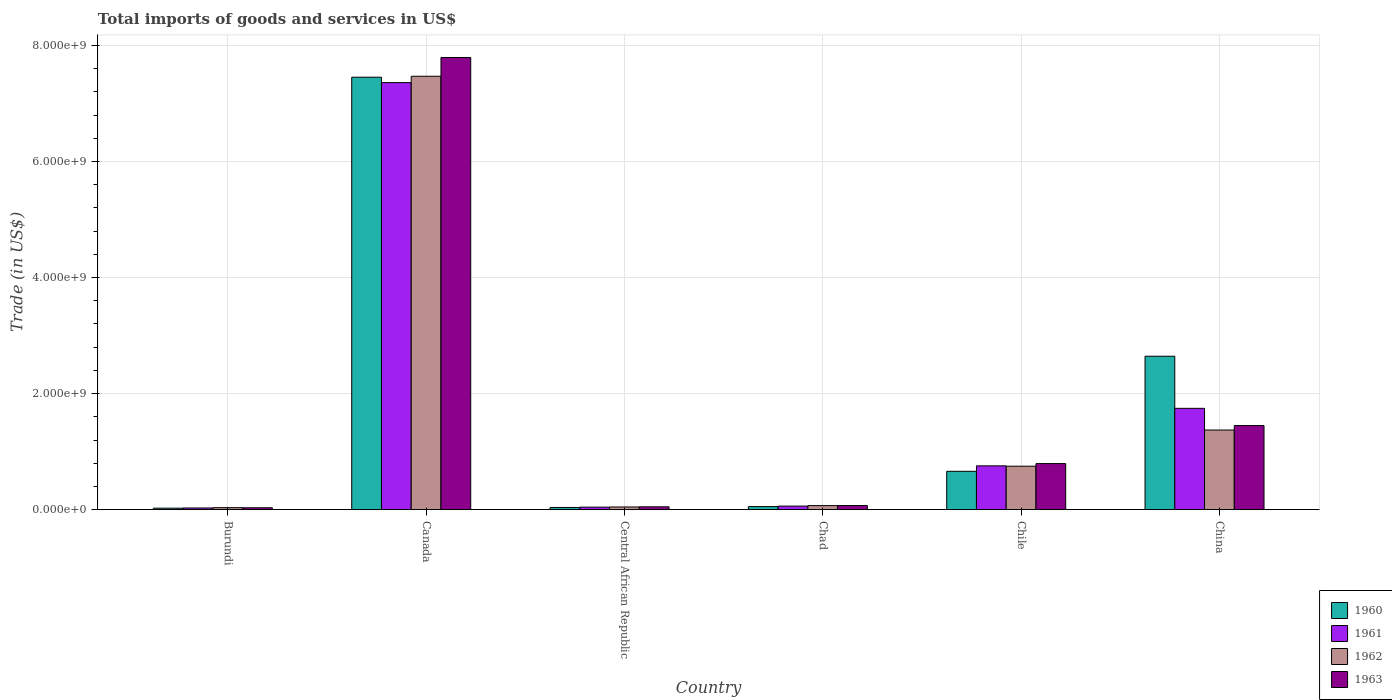How many different coloured bars are there?
Your response must be concise. 4. Are the number of bars on each tick of the X-axis equal?
Keep it short and to the point. Yes. How many bars are there on the 4th tick from the left?
Provide a short and direct response. 4. What is the label of the 1st group of bars from the left?
Provide a succinct answer. Burundi. What is the total imports of goods and services in 1961 in China?
Provide a short and direct response. 1.75e+09. Across all countries, what is the maximum total imports of goods and services in 1962?
Offer a very short reply. 7.47e+09. Across all countries, what is the minimum total imports of goods and services in 1960?
Offer a very short reply. 2.62e+07. In which country was the total imports of goods and services in 1963 minimum?
Offer a terse response. Burundi. What is the total total imports of goods and services in 1961 in the graph?
Provide a succinct answer. 1.00e+1. What is the difference between the total imports of goods and services in 1962 in Central African Republic and that in China?
Offer a very short reply. -1.33e+09. What is the difference between the total imports of goods and services in 1960 in Burundi and the total imports of goods and services in 1961 in Central African Republic?
Ensure brevity in your answer.  -1.78e+07. What is the average total imports of goods and services in 1960 per country?
Ensure brevity in your answer.  1.81e+09. What is the difference between the total imports of goods and services of/in 1963 and total imports of goods and services of/in 1961 in Central African Republic?
Give a very brief answer. 5.76e+06. What is the ratio of the total imports of goods and services in 1963 in Burundi to that in Chad?
Ensure brevity in your answer.  0.47. Is the total imports of goods and services in 1963 in Canada less than that in Chile?
Your answer should be very brief. No. Is the difference between the total imports of goods and services in 1963 in Burundi and Canada greater than the difference between the total imports of goods and services in 1961 in Burundi and Canada?
Your answer should be very brief. No. What is the difference between the highest and the second highest total imports of goods and services in 1960?
Your answer should be very brief. -1.98e+09. What is the difference between the highest and the lowest total imports of goods and services in 1961?
Your response must be concise. 7.33e+09. In how many countries, is the total imports of goods and services in 1963 greater than the average total imports of goods and services in 1963 taken over all countries?
Provide a short and direct response. 1. Is the sum of the total imports of goods and services in 1963 in Central African Republic and China greater than the maximum total imports of goods and services in 1960 across all countries?
Provide a succinct answer. No. What does the 3rd bar from the left in Burundi represents?
Keep it short and to the point. 1962. What does the 2nd bar from the right in Canada represents?
Give a very brief answer. 1962. Is it the case that in every country, the sum of the total imports of goods and services in 1962 and total imports of goods and services in 1960 is greater than the total imports of goods and services in 1963?
Ensure brevity in your answer.  Yes. How many countries are there in the graph?
Your answer should be very brief. 6. Does the graph contain any zero values?
Keep it short and to the point. No. Does the graph contain grids?
Offer a terse response. Yes. What is the title of the graph?
Your answer should be compact. Total imports of goods and services in US$. What is the label or title of the X-axis?
Provide a succinct answer. Country. What is the label or title of the Y-axis?
Your answer should be compact. Trade (in US$). What is the Trade (in US$) in 1960 in Burundi?
Keep it short and to the point. 2.62e+07. What is the Trade (in US$) in 1961 in Burundi?
Provide a succinct answer. 2.98e+07. What is the Trade (in US$) in 1962 in Burundi?
Make the answer very short. 3.50e+07. What is the Trade (in US$) of 1963 in Burundi?
Your answer should be very brief. 3.32e+07. What is the Trade (in US$) of 1960 in Canada?
Give a very brief answer. 7.45e+09. What is the Trade (in US$) in 1961 in Canada?
Make the answer very short. 7.36e+09. What is the Trade (in US$) in 1962 in Canada?
Offer a terse response. 7.47e+09. What is the Trade (in US$) of 1963 in Canada?
Offer a very short reply. 7.79e+09. What is the Trade (in US$) of 1960 in Central African Republic?
Make the answer very short. 3.83e+07. What is the Trade (in US$) in 1961 in Central African Republic?
Give a very brief answer. 4.40e+07. What is the Trade (in US$) of 1962 in Central African Republic?
Your answer should be compact. 4.69e+07. What is the Trade (in US$) in 1963 in Central African Republic?
Your answer should be compact. 4.98e+07. What is the Trade (in US$) of 1960 in Chad?
Give a very brief answer. 5.34e+07. What is the Trade (in US$) in 1961 in Chad?
Ensure brevity in your answer.  6.20e+07. What is the Trade (in US$) of 1962 in Chad?
Offer a very short reply. 7.02e+07. What is the Trade (in US$) in 1963 in Chad?
Offer a very short reply. 7.14e+07. What is the Trade (in US$) in 1960 in Chile?
Offer a very short reply. 6.62e+08. What is the Trade (in US$) of 1961 in Chile?
Provide a succinct answer. 7.55e+08. What is the Trade (in US$) of 1962 in Chile?
Your response must be concise. 7.50e+08. What is the Trade (in US$) of 1963 in Chile?
Offer a terse response. 7.95e+08. What is the Trade (in US$) of 1960 in China?
Ensure brevity in your answer.  2.64e+09. What is the Trade (in US$) in 1961 in China?
Ensure brevity in your answer.  1.75e+09. What is the Trade (in US$) of 1962 in China?
Make the answer very short. 1.37e+09. What is the Trade (in US$) of 1963 in China?
Ensure brevity in your answer.  1.45e+09. Across all countries, what is the maximum Trade (in US$) in 1960?
Make the answer very short. 7.45e+09. Across all countries, what is the maximum Trade (in US$) in 1961?
Keep it short and to the point. 7.36e+09. Across all countries, what is the maximum Trade (in US$) in 1962?
Ensure brevity in your answer.  7.47e+09. Across all countries, what is the maximum Trade (in US$) of 1963?
Offer a terse response. 7.79e+09. Across all countries, what is the minimum Trade (in US$) of 1960?
Make the answer very short. 2.62e+07. Across all countries, what is the minimum Trade (in US$) of 1961?
Give a very brief answer. 2.98e+07. Across all countries, what is the minimum Trade (in US$) in 1962?
Keep it short and to the point. 3.50e+07. Across all countries, what is the minimum Trade (in US$) in 1963?
Provide a short and direct response. 3.32e+07. What is the total Trade (in US$) of 1960 in the graph?
Provide a short and direct response. 1.09e+1. What is the total Trade (in US$) in 1961 in the graph?
Your answer should be compact. 1.00e+1. What is the total Trade (in US$) of 1962 in the graph?
Your answer should be compact. 9.74e+09. What is the total Trade (in US$) in 1963 in the graph?
Offer a very short reply. 1.02e+1. What is the difference between the Trade (in US$) of 1960 in Burundi and that in Canada?
Offer a terse response. -7.43e+09. What is the difference between the Trade (in US$) of 1961 in Burundi and that in Canada?
Offer a terse response. -7.33e+09. What is the difference between the Trade (in US$) of 1962 in Burundi and that in Canada?
Provide a short and direct response. -7.43e+09. What is the difference between the Trade (in US$) in 1963 in Burundi and that in Canada?
Ensure brevity in your answer.  -7.76e+09. What is the difference between the Trade (in US$) of 1960 in Burundi and that in Central African Republic?
Provide a succinct answer. -1.21e+07. What is the difference between the Trade (in US$) in 1961 in Burundi and that in Central African Republic?
Offer a terse response. -1.43e+07. What is the difference between the Trade (in US$) in 1962 in Burundi and that in Central African Republic?
Provide a succinct answer. -1.19e+07. What is the difference between the Trade (in US$) in 1963 in Burundi and that in Central African Republic?
Offer a terse response. -1.65e+07. What is the difference between the Trade (in US$) of 1960 in Burundi and that in Chad?
Your answer should be very brief. -2.72e+07. What is the difference between the Trade (in US$) of 1961 in Burundi and that in Chad?
Ensure brevity in your answer.  -3.22e+07. What is the difference between the Trade (in US$) in 1962 in Burundi and that in Chad?
Your answer should be very brief. -3.52e+07. What is the difference between the Trade (in US$) of 1963 in Burundi and that in Chad?
Offer a terse response. -3.82e+07. What is the difference between the Trade (in US$) in 1960 in Burundi and that in Chile?
Provide a succinct answer. -6.35e+08. What is the difference between the Trade (in US$) of 1961 in Burundi and that in Chile?
Make the answer very short. -7.26e+08. What is the difference between the Trade (in US$) of 1962 in Burundi and that in Chile?
Your answer should be compact. -7.15e+08. What is the difference between the Trade (in US$) in 1963 in Burundi and that in Chile?
Keep it short and to the point. -7.61e+08. What is the difference between the Trade (in US$) in 1960 in Burundi and that in China?
Your answer should be compact. -2.62e+09. What is the difference between the Trade (in US$) in 1961 in Burundi and that in China?
Give a very brief answer. -1.72e+09. What is the difference between the Trade (in US$) of 1962 in Burundi and that in China?
Offer a terse response. -1.34e+09. What is the difference between the Trade (in US$) in 1963 in Burundi and that in China?
Your answer should be very brief. -1.42e+09. What is the difference between the Trade (in US$) in 1960 in Canada and that in Central African Republic?
Provide a succinct answer. 7.41e+09. What is the difference between the Trade (in US$) in 1961 in Canada and that in Central African Republic?
Your answer should be very brief. 7.32e+09. What is the difference between the Trade (in US$) of 1962 in Canada and that in Central African Republic?
Ensure brevity in your answer.  7.42e+09. What is the difference between the Trade (in US$) of 1963 in Canada and that in Central African Republic?
Provide a short and direct response. 7.74e+09. What is the difference between the Trade (in US$) in 1960 in Canada and that in Chad?
Give a very brief answer. 7.40e+09. What is the difference between the Trade (in US$) of 1961 in Canada and that in Chad?
Ensure brevity in your answer.  7.30e+09. What is the difference between the Trade (in US$) in 1962 in Canada and that in Chad?
Your response must be concise. 7.40e+09. What is the difference between the Trade (in US$) in 1963 in Canada and that in Chad?
Give a very brief answer. 7.72e+09. What is the difference between the Trade (in US$) of 1960 in Canada and that in Chile?
Offer a very short reply. 6.79e+09. What is the difference between the Trade (in US$) of 1961 in Canada and that in Chile?
Offer a very short reply. 6.60e+09. What is the difference between the Trade (in US$) in 1962 in Canada and that in Chile?
Ensure brevity in your answer.  6.72e+09. What is the difference between the Trade (in US$) in 1963 in Canada and that in Chile?
Give a very brief answer. 7.00e+09. What is the difference between the Trade (in US$) in 1960 in Canada and that in China?
Ensure brevity in your answer.  4.81e+09. What is the difference between the Trade (in US$) of 1961 in Canada and that in China?
Provide a succinct answer. 5.61e+09. What is the difference between the Trade (in US$) in 1962 in Canada and that in China?
Your response must be concise. 6.10e+09. What is the difference between the Trade (in US$) of 1963 in Canada and that in China?
Your answer should be very brief. 6.34e+09. What is the difference between the Trade (in US$) in 1960 in Central African Republic and that in Chad?
Provide a short and direct response. -1.51e+07. What is the difference between the Trade (in US$) in 1961 in Central African Republic and that in Chad?
Your response must be concise. -1.79e+07. What is the difference between the Trade (in US$) in 1962 in Central African Republic and that in Chad?
Offer a terse response. -2.33e+07. What is the difference between the Trade (in US$) in 1963 in Central African Republic and that in Chad?
Offer a very short reply. -2.16e+07. What is the difference between the Trade (in US$) in 1960 in Central African Republic and that in Chile?
Make the answer very short. -6.23e+08. What is the difference between the Trade (in US$) in 1961 in Central African Republic and that in Chile?
Your answer should be very brief. -7.11e+08. What is the difference between the Trade (in US$) of 1962 in Central African Republic and that in Chile?
Your answer should be very brief. -7.03e+08. What is the difference between the Trade (in US$) in 1963 in Central African Republic and that in Chile?
Make the answer very short. -7.45e+08. What is the difference between the Trade (in US$) of 1960 in Central African Republic and that in China?
Provide a succinct answer. -2.61e+09. What is the difference between the Trade (in US$) of 1961 in Central African Republic and that in China?
Provide a short and direct response. -1.70e+09. What is the difference between the Trade (in US$) of 1962 in Central African Republic and that in China?
Keep it short and to the point. -1.33e+09. What is the difference between the Trade (in US$) in 1963 in Central African Republic and that in China?
Your answer should be compact. -1.40e+09. What is the difference between the Trade (in US$) in 1960 in Chad and that in Chile?
Your answer should be compact. -6.08e+08. What is the difference between the Trade (in US$) in 1961 in Chad and that in Chile?
Provide a succinct answer. -6.93e+08. What is the difference between the Trade (in US$) of 1962 in Chad and that in Chile?
Provide a short and direct response. -6.80e+08. What is the difference between the Trade (in US$) of 1963 in Chad and that in Chile?
Give a very brief answer. -7.23e+08. What is the difference between the Trade (in US$) of 1960 in Chad and that in China?
Your answer should be compact. -2.59e+09. What is the difference between the Trade (in US$) in 1961 in Chad and that in China?
Make the answer very short. -1.68e+09. What is the difference between the Trade (in US$) of 1962 in Chad and that in China?
Your answer should be compact. -1.30e+09. What is the difference between the Trade (in US$) in 1963 in Chad and that in China?
Offer a very short reply. -1.38e+09. What is the difference between the Trade (in US$) in 1960 in Chile and that in China?
Your answer should be compact. -1.98e+09. What is the difference between the Trade (in US$) in 1961 in Chile and that in China?
Your answer should be compact. -9.91e+08. What is the difference between the Trade (in US$) of 1962 in Chile and that in China?
Keep it short and to the point. -6.23e+08. What is the difference between the Trade (in US$) in 1963 in Chile and that in China?
Offer a terse response. -6.55e+08. What is the difference between the Trade (in US$) in 1960 in Burundi and the Trade (in US$) in 1961 in Canada?
Make the answer very short. -7.33e+09. What is the difference between the Trade (in US$) of 1960 in Burundi and the Trade (in US$) of 1962 in Canada?
Your answer should be compact. -7.44e+09. What is the difference between the Trade (in US$) in 1960 in Burundi and the Trade (in US$) in 1963 in Canada?
Keep it short and to the point. -7.77e+09. What is the difference between the Trade (in US$) of 1961 in Burundi and the Trade (in US$) of 1962 in Canada?
Your answer should be very brief. -7.44e+09. What is the difference between the Trade (in US$) of 1961 in Burundi and the Trade (in US$) of 1963 in Canada?
Make the answer very short. -7.76e+09. What is the difference between the Trade (in US$) of 1962 in Burundi and the Trade (in US$) of 1963 in Canada?
Provide a succinct answer. -7.76e+09. What is the difference between the Trade (in US$) in 1960 in Burundi and the Trade (in US$) in 1961 in Central African Republic?
Your answer should be compact. -1.78e+07. What is the difference between the Trade (in US$) in 1960 in Burundi and the Trade (in US$) in 1962 in Central African Republic?
Offer a very short reply. -2.07e+07. What is the difference between the Trade (in US$) in 1960 in Burundi and the Trade (in US$) in 1963 in Central African Republic?
Give a very brief answer. -2.35e+07. What is the difference between the Trade (in US$) of 1961 in Burundi and the Trade (in US$) of 1962 in Central African Republic?
Your answer should be compact. -1.72e+07. What is the difference between the Trade (in US$) in 1961 in Burundi and the Trade (in US$) in 1963 in Central African Republic?
Your answer should be very brief. -2.00e+07. What is the difference between the Trade (in US$) in 1962 in Burundi and the Trade (in US$) in 1963 in Central African Republic?
Make the answer very short. -1.48e+07. What is the difference between the Trade (in US$) in 1960 in Burundi and the Trade (in US$) in 1961 in Chad?
Your answer should be very brief. -3.57e+07. What is the difference between the Trade (in US$) of 1960 in Burundi and the Trade (in US$) of 1962 in Chad?
Offer a terse response. -4.40e+07. What is the difference between the Trade (in US$) of 1960 in Burundi and the Trade (in US$) of 1963 in Chad?
Your answer should be compact. -4.52e+07. What is the difference between the Trade (in US$) in 1961 in Burundi and the Trade (in US$) in 1962 in Chad?
Offer a terse response. -4.05e+07. What is the difference between the Trade (in US$) in 1961 in Burundi and the Trade (in US$) in 1963 in Chad?
Keep it short and to the point. -4.17e+07. What is the difference between the Trade (in US$) of 1962 in Burundi and the Trade (in US$) of 1963 in Chad?
Provide a short and direct response. -3.64e+07. What is the difference between the Trade (in US$) in 1960 in Burundi and the Trade (in US$) in 1961 in Chile?
Make the answer very short. -7.29e+08. What is the difference between the Trade (in US$) in 1960 in Burundi and the Trade (in US$) in 1962 in Chile?
Your response must be concise. -7.23e+08. What is the difference between the Trade (in US$) in 1960 in Burundi and the Trade (in US$) in 1963 in Chile?
Keep it short and to the point. -7.68e+08. What is the difference between the Trade (in US$) of 1961 in Burundi and the Trade (in US$) of 1962 in Chile?
Your answer should be compact. -7.20e+08. What is the difference between the Trade (in US$) in 1961 in Burundi and the Trade (in US$) in 1963 in Chile?
Offer a terse response. -7.65e+08. What is the difference between the Trade (in US$) in 1962 in Burundi and the Trade (in US$) in 1963 in Chile?
Offer a terse response. -7.60e+08. What is the difference between the Trade (in US$) in 1960 in Burundi and the Trade (in US$) in 1961 in China?
Keep it short and to the point. -1.72e+09. What is the difference between the Trade (in US$) in 1960 in Burundi and the Trade (in US$) in 1962 in China?
Offer a very short reply. -1.35e+09. What is the difference between the Trade (in US$) in 1960 in Burundi and the Trade (in US$) in 1963 in China?
Keep it short and to the point. -1.42e+09. What is the difference between the Trade (in US$) of 1961 in Burundi and the Trade (in US$) of 1962 in China?
Keep it short and to the point. -1.34e+09. What is the difference between the Trade (in US$) of 1961 in Burundi and the Trade (in US$) of 1963 in China?
Provide a short and direct response. -1.42e+09. What is the difference between the Trade (in US$) of 1962 in Burundi and the Trade (in US$) of 1963 in China?
Your answer should be very brief. -1.42e+09. What is the difference between the Trade (in US$) in 1960 in Canada and the Trade (in US$) in 1961 in Central African Republic?
Ensure brevity in your answer.  7.41e+09. What is the difference between the Trade (in US$) of 1960 in Canada and the Trade (in US$) of 1962 in Central African Republic?
Provide a succinct answer. 7.41e+09. What is the difference between the Trade (in US$) of 1960 in Canada and the Trade (in US$) of 1963 in Central African Republic?
Your response must be concise. 7.40e+09. What is the difference between the Trade (in US$) in 1961 in Canada and the Trade (in US$) in 1962 in Central African Republic?
Your answer should be compact. 7.31e+09. What is the difference between the Trade (in US$) in 1961 in Canada and the Trade (in US$) in 1963 in Central African Republic?
Keep it short and to the point. 7.31e+09. What is the difference between the Trade (in US$) of 1962 in Canada and the Trade (in US$) of 1963 in Central African Republic?
Ensure brevity in your answer.  7.42e+09. What is the difference between the Trade (in US$) of 1960 in Canada and the Trade (in US$) of 1961 in Chad?
Your response must be concise. 7.39e+09. What is the difference between the Trade (in US$) in 1960 in Canada and the Trade (in US$) in 1962 in Chad?
Your answer should be very brief. 7.38e+09. What is the difference between the Trade (in US$) in 1960 in Canada and the Trade (in US$) in 1963 in Chad?
Offer a terse response. 7.38e+09. What is the difference between the Trade (in US$) of 1961 in Canada and the Trade (in US$) of 1962 in Chad?
Your answer should be compact. 7.29e+09. What is the difference between the Trade (in US$) in 1961 in Canada and the Trade (in US$) in 1963 in Chad?
Your response must be concise. 7.29e+09. What is the difference between the Trade (in US$) of 1962 in Canada and the Trade (in US$) of 1963 in Chad?
Give a very brief answer. 7.40e+09. What is the difference between the Trade (in US$) in 1960 in Canada and the Trade (in US$) in 1961 in Chile?
Provide a succinct answer. 6.70e+09. What is the difference between the Trade (in US$) of 1960 in Canada and the Trade (in US$) of 1962 in Chile?
Your answer should be very brief. 6.70e+09. What is the difference between the Trade (in US$) in 1960 in Canada and the Trade (in US$) in 1963 in Chile?
Ensure brevity in your answer.  6.66e+09. What is the difference between the Trade (in US$) in 1961 in Canada and the Trade (in US$) in 1962 in Chile?
Make the answer very short. 6.61e+09. What is the difference between the Trade (in US$) in 1961 in Canada and the Trade (in US$) in 1963 in Chile?
Give a very brief answer. 6.56e+09. What is the difference between the Trade (in US$) of 1962 in Canada and the Trade (in US$) of 1963 in Chile?
Provide a succinct answer. 6.67e+09. What is the difference between the Trade (in US$) of 1960 in Canada and the Trade (in US$) of 1961 in China?
Offer a terse response. 5.71e+09. What is the difference between the Trade (in US$) of 1960 in Canada and the Trade (in US$) of 1962 in China?
Offer a very short reply. 6.08e+09. What is the difference between the Trade (in US$) in 1960 in Canada and the Trade (in US$) in 1963 in China?
Offer a terse response. 6.00e+09. What is the difference between the Trade (in US$) in 1961 in Canada and the Trade (in US$) in 1962 in China?
Offer a terse response. 5.99e+09. What is the difference between the Trade (in US$) in 1961 in Canada and the Trade (in US$) in 1963 in China?
Your answer should be compact. 5.91e+09. What is the difference between the Trade (in US$) in 1962 in Canada and the Trade (in US$) in 1963 in China?
Your response must be concise. 6.02e+09. What is the difference between the Trade (in US$) of 1960 in Central African Republic and the Trade (in US$) of 1961 in Chad?
Provide a short and direct response. -2.36e+07. What is the difference between the Trade (in US$) in 1960 in Central African Republic and the Trade (in US$) in 1962 in Chad?
Provide a succinct answer. -3.19e+07. What is the difference between the Trade (in US$) in 1960 in Central African Republic and the Trade (in US$) in 1963 in Chad?
Make the answer very short. -3.31e+07. What is the difference between the Trade (in US$) in 1961 in Central African Republic and the Trade (in US$) in 1962 in Chad?
Provide a succinct answer. -2.62e+07. What is the difference between the Trade (in US$) in 1961 in Central African Republic and the Trade (in US$) in 1963 in Chad?
Your answer should be very brief. -2.74e+07. What is the difference between the Trade (in US$) in 1962 in Central African Republic and the Trade (in US$) in 1963 in Chad?
Offer a very short reply. -2.45e+07. What is the difference between the Trade (in US$) in 1960 in Central African Republic and the Trade (in US$) in 1961 in Chile?
Offer a terse response. -7.17e+08. What is the difference between the Trade (in US$) of 1960 in Central African Republic and the Trade (in US$) of 1962 in Chile?
Your answer should be very brief. -7.11e+08. What is the difference between the Trade (in US$) of 1960 in Central African Republic and the Trade (in US$) of 1963 in Chile?
Offer a terse response. -7.56e+08. What is the difference between the Trade (in US$) in 1961 in Central African Republic and the Trade (in US$) in 1962 in Chile?
Provide a succinct answer. -7.06e+08. What is the difference between the Trade (in US$) in 1961 in Central African Republic and the Trade (in US$) in 1963 in Chile?
Provide a succinct answer. -7.51e+08. What is the difference between the Trade (in US$) of 1962 in Central African Republic and the Trade (in US$) of 1963 in Chile?
Provide a short and direct response. -7.48e+08. What is the difference between the Trade (in US$) in 1960 in Central African Republic and the Trade (in US$) in 1961 in China?
Ensure brevity in your answer.  -1.71e+09. What is the difference between the Trade (in US$) of 1960 in Central African Republic and the Trade (in US$) of 1962 in China?
Provide a succinct answer. -1.33e+09. What is the difference between the Trade (in US$) in 1960 in Central African Republic and the Trade (in US$) in 1963 in China?
Offer a very short reply. -1.41e+09. What is the difference between the Trade (in US$) in 1961 in Central African Republic and the Trade (in US$) in 1962 in China?
Provide a short and direct response. -1.33e+09. What is the difference between the Trade (in US$) in 1961 in Central African Republic and the Trade (in US$) in 1963 in China?
Your answer should be compact. -1.41e+09. What is the difference between the Trade (in US$) of 1962 in Central African Republic and the Trade (in US$) of 1963 in China?
Offer a terse response. -1.40e+09. What is the difference between the Trade (in US$) of 1960 in Chad and the Trade (in US$) of 1961 in Chile?
Offer a terse response. -7.02e+08. What is the difference between the Trade (in US$) in 1960 in Chad and the Trade (in US$) in 1962 in Chile?
Provide a succinct answer. -6.96e+08. What is the difference between the Trade (in US$) in 1960 in Chad and the Trade (in US$) in 1963 in Chile?
Keep it short and to the point. -7.41e+08. What is the difference between the Trade (in US$) of 1961 in Chad and the Trade (in US$) of 1962 in Chile?
Your answer should be very brief. -6.88e+08. What is the difference between the Trade (in US$) in 1961 in Chad and the Trade (in US$) in 1963 in Chile?
Give a very brief answer. -7.33e+08. What is the difference between the Trade (in US$) in 1962 in Chad and the Trade (in US$) in 1963 in Chile?
Your answer should be compact. -7.25e+08. What is the difference between the Trade (in US$) in 1960 in Chad and the Trade (in US$) in 1961 in China?
Your answer should be compact. -1.69e+09. What is the difference between the Trade (in US$) of 1960 in Chad and the Trade (in US$) of 1962 in China?
Keep it short and to the point. -1.32e+09. What is the difference between the Trade (in US$) of 1960 in Chad and the Trade (in US$) of 1963 in China?
Offer a very short reply. -1.40e+09. What is the difference between the Trade (in US$) of 1961 in Chad and the Trade (in US$) of 1962 in China?
Offer a terse response. -1.31e+09. What is the difference between the Trade (in US$) of 1961 in Chad and the Trade (in US$) of 1963 in China?
Provide a short and direct response. -1.39e+09. What is the difference between the Trade (in US$) in 1962 in Chad and the Trade (in US$) in 1963 in China?
Your response must be concise. -1.38e+09. What is the difference between the Trade (in US$) in 1960 in Chile and the Trade (in US$) in 1961 in China?
Give a very brief answer. -1.09e+09. What is the difference between the Trade (in US$) of 1960 in Chile and the Trade (in US$) of 1962 in China?
Provide a succinct answer. -7.11e+08. What is the difference between the Trade (in US$) in 1960 in Chile and the Trade (in US$) in 1963 in China?
Your response must be concise. -7.88e+08. What is the difference between the Trade (in US$) in 1961 in Chile and the Trade (in US$) in 1962 in China?
Give a very brief answer. -6.18e+08. What is the difference between the Trade (in US$) of 1961 in Chile and the Trade (in US$) of 1963 in China?
Keep it short and to the point. -6.95e+08. What is the difference between the Trade (in US$) of 1962 in Chile and the Trade (in US$) of 1963 in China?
Ensure brevity in your answer.  -7.00e+08. What is the average Trade (in US$) in 1960 per country?
Provide a short and direct response. 1.81e+09. What is the average Trade (in US$) of 1961 per country?
Ensure brevity in your answer.  1.67e+09. What is the average Trade (in US$) in 1962 per country?
Your response must be concise. 1.62e+09. What is the average Trade (in US$) of 1963 per country?
Provide a succinct answer. 1.70e+09. What is the difference between the Trade (in US$) of 1960 and Trade (in US$) of 1961 in Burundi?
Your answer should be compact. -3.50e+06. What is the difference between the Trade (in US$) of 1960 and Trade (in US$) of 1962 in Burundi?
Provide a succinct answer. -8.75e+06. What is the difference between the Trade (in US$) of 1960 and Trade (in US$) of 1963 in Burundi?
Make the answer very short. -7.00e+06. What is the difference between the Trade (in US$) in 1961 and Trade (in US$) in 1962 in Burundi?
Your response must be concise. -5.25e+06. What is the difference between the Trade (in US$) in 1961 and Trade (in US$) in 1963 in Burundi?
Offer a terse response. -3.50e+06. What is the difference between the Trade (in US$) of 1962 and Trade (in US$) of 1963 in Burundi?
Provide a short and direct response. 1.75e+06. What is the difference between the Trade (in US$) of 1960 and Trade (in US$) of 1961 in Canada?
Offer a terse response. 9.32e+07. What is the difference between the Trade (in US$) in 1960 and Trade (in US$) in 1962 in Canada?
Your answer should be compact. -1.67e+07. What is the difference between the Trade (in US$) of 1960 and Trade (in US$) of 1963 in Canada?
Your response must be concise. -3.40e+08. What is the difference between the Trade (in US$) in 1961 and Trade (in US$) in 1962 in Canada?
Make the answer very short. -1.10e+08. What is the difference between the Trade (in US$) of 1961 and Trade (in US$) of 1963 in Canada?
Provide a succinct answer. -4.33e+08. What is the difference between the Trade (in US$) in 1962 and Trade (in US$) in 1963 in Canada?
Provide a short and direct response. -3.23e+08. What is the difference between the Trade (in US$) of 1960 and Trade (in US$) of 1961 in Central African Republic?
Provide a short and direct response. -5.70e+06. What is the difference between the Trade (in US$) in 1960 and Trade (in US$) in 1962 in Central African Republic?
Offer a terse response. -8.60e+06. What is the difference between the Trade (in US$) in 1960 and Trade (in US$) in 1963 in Central African Republic?
Offer a very short reply. -1.15e+07. What is the difference between the Trade (in US$) of 1961 and Trade (in US$) of 1962 in Central African Republic?
Your answer should be very brief. -2.90e+06. What is the difference between the Trade (in US$) of 1961 and Trade (in US$) of 1963 in Central African Republic?
Offer a terse response. -5.76e+06. What is the difference between the Trade (in US$) of 1962 and Trade (in US$) of 1963 in Central African Republic?
Keep it short and to the point. -2.86e+06. What is the difference between the Trade (in US$) in 1960 and Trade (in US$) in 1961 in Chad?
Offer a very short reply. -8.55e+06. What is the difference between the Trade (in US$) of 1960 and Trade (in US$) of 1962 in Chad?
Your answer should be very brief. -1.68e+07. What is the difference between the Trade (in US$) of 1960 and Trade (in US$) of 1963 in Chad?
Give a very brief answer. -1.80e+07. What is the difference between the Trade (in US$) of 1961 and Trade (in US$) of 1962 in Chad?
Make the answer very short. -8.23e+06. What is the difference between the Trade (in US$) in 1961 and Trade (in US$) in 1963 in Chad?
Ensure brevity in your answer.  -9.45e+06. What is the difference between the Trade (in US$) of 1962 and Trade (in US$) of 1963 in Chad?
Offer a very short reply. -1.22e+06. What is the difference between the Trade (in US$) of 1960 and Trade (in US$) of 1961 in Chile?
Offer a very short reply. -9.38e+07. What is the difference between the Trade (in US$) in 1960 and Trade (in US$) in 1962 in Chile?
Ensure brevity in your answer.  -8.81e+07. What is the difference between the Trade (in US$) of 1960 and Trade (in US$) of 1963 in Chile?
Offer a terse response. -1.33e+08. What is the difference between the Trade (in US$) in 1961 and Trade (in US$) in 1962 in Chile?
Provide a short and direct response. 5.71e+06. What is the difference between the Trade (in US$) of 1961 and Trade (in US$) of 1963 in Chile?
Provide a succinct answer. -3.92e+07. What is the difference between the Trade (in US$) of 1962 and Trade (in US$) of 1963 in Chile?
Keep it short and to the point. -4.50e+07. What is the difference between the Trade (in US$) of 1960 and Trade (in US$) of 1961 in China?
Your answer should be very brief. 8.98e+08. What is the difference between the Trade (in US$) in 1960 and Trade (in US$) in 1962 in China?
Offer a terse response. 1.27e+09. What is the difference between the Trade (in US$) in 1960 and Trade (in US$) in 1963 in China?
Offer a terse response. 1.19e+09. What is the difference between the Trade (in US$) in 1961 and Trade (in US$) in 1962 in China?
Your answer should be compact. 3.74e+08. What is the difference between the Trade (in US$) in 1961 and Trade (in US$) in 1963 in China?
Provide a short and direct response. 2.97e+08. What is the difference between the Trade (in US$) of 1962 and Trade (in US$) of 1963 in China?
Your response must be concise. -7.72e+07. What is the ratio of the Trade (in US$) of 1960 in Burundi to that in Canada?
Offer a terse response. 0. What is the ratio of the Trade (in US$) of 1961 in Burundi to that in Canada?
Your answer should be compact. 0. What is the ratio of the Trade (in US$) of 1962 in Burundi to that in Canada?
Provide a succinct answer. 0. What is the ratio of the Trade (in US$) of 1963 in Burundi to that in Canada?
Ensure brevity in your answer.  0. What is the ratio of the Trade (in US$) of 1960 in Burundi to that in Central African Republic?
Your response must be concise. 0.68. What is the ratio of the Trade (in US$) in 1961 in Burundi to that in Central African Republic?
Ensure brevity in your answer.  0.68. What is the ratio of the Trade (in US$) of 1962 in Burundi to that in Central African Republic?
Provide a short and direct response. 0.75. What is the ratio of the Trade (in US$) in 1963 in Burundi to that in Central African Republic?
Offer a very short reply. 0.67. What is the ratio of the Trade (in US$) in 1960 in Burundi to that in Chad?
Your response must be concise. 0.49. What is the ratio of the Trade (in US$) of 1961 in Burundi to that in Chad?
Give a very brief answer. 0.48. What is the ratio of the Trade (in US$) in 1962 in Burundi to that in Chad?
Offer a very short reply. 0.5. What is the ratio of the Trade (in US$) of 1963 in Burundi to that in Chad?
Ensure brevity in your answer.  0.47. What is the ratio of the Trade (in US$) in 1960 in Burundi to that in Chile?
Your response must be concise. 0.04. What is the ratio of the Trade (in US$) in 1961 in Burundi to that in Chile?
Provide a succinct answer. 0.04. What is the ratio of the Trade (in US$) of 1962 in Burundi to that in Chile?
Your response must be concise. 0.05. What is the ratio of the Trade (in US$) of 1963 in Burundi to that in Chile?
Keep it short and to the point. 0.04. What is the ratio of the Trade (in US$) of 1960 in Burundi to that in China?
Your response must be concise. 0.01. What is the ratio of the Trade (in US$) of 1961 in Burundi to that in China?
Provide a succinct answer. 0.02. What is the ratio of the Trade (in US$) in 1962 in Burundi to that in China?
Ensure brevity in your answer.  0.03. What is the ratio of the Trade (in US$) in 1963 in Burundi to that in China?
Give a very brief answer. 0.02. What is the ratio of the Trade (in US$) of 1960 in Canada to that in Central African Republic?
Ensure brevity in your answer.  194.4. What is the ratio of the Trade (in US$) of 1961 in Canada to that in Central African Republic?
Give a very brief answer. 167.13. What is the ratio of the Trade (in US$) of 1962 in Canada to that in Central African Republic?
Your response must be concise. 159.14. What is the ratio of the Trade (in US$) of 1963 in Canada to that in Central African Republic?
Your response must be concise. 156.5. What is the ratio of the Trade (in US$) in 1960 in Canada to that in Chad?
Provide a succinct answer. 139.49. What is the ratio of the Trade (in US$) of 1961 in Canada to that in Chad?
Your answer should be compact. 118.75. What is the ratio of the Trade (in US$) of 1962 in Canada to that in Chad?
Offer a very short reply. 106.4. What is the ratio of the Trade (in US$) in 1963 in Canada to that in Chad?
Offer a terse response. 109.1. What is the ratio of the Trade (in US$) of 1960 in Canada to that in Chile?
Give a very brief answer. 11.26. What is the ratio of the Trade (in US$) of 1961 in Canada to that in Chile?
Give a very brief answer. 9.74. What is the ratio of the Trade (in US$) of 1962 in Canada to that in Chile?
Your response must be concise. 9.96. What is the ratio of the Trade (in US$) in 1963 in Canada to that in Chile?
Your answer should be very brief. 9.81. What is the ratio of the Trade (in US$) in 1960 in Canada to that in China?
Ensure brevity in your answer.  2.82. What is the ratio of the Trade (in US$) in 1961 in Canada to that in China?
Provide a short and direct response. 4.21. What is the ratio of the Trade (in US$) in 1962 in Canada to that in China?
Keep it short and to the point. 5.44. What is the ratio of the Trade (in US$) in 1963 in Canada to that in China?
Provide a short and direct response. 5.37. What is the ratio of the Trade (in US$) in 1960 in Central African Republic to that in Chad?
Offer a terse response. 0.72. What is the ratio of the Trade (in US$) of 1961 in Central African Republic to that in Chad?
Give a very brief answer. 0.71. What is the ratio of the Trade (in US$) in 1962 in Central African Republic to that in Chad?
Provide a succinct answer. 0.67. What is the ratio of the Trade (in US$) of 1963 in Central African Republic to that in Chad?
Ensure brevity in your answer.  0.7. What is the ratio of the Trade (in US$) in 1960 in Central African Republic to that in Chile?
Offer a very short reply. 0.06. What is the ratio of the Trade (in US$) in 1961 in Central African Republic to that in Chile?
Keep it short and to the point. 0.06. What is the ratio of the Trade (in US$) of 1962 in Central African Republic to that in Chile?
Keep it short and to the point. 0.06. What is the ratio of the Trade (in US$) of 1963 in Central African Republic to that in Chile?
Your response must be concise. 0.06. What is the ratio of the Trade (in US$) of 1960 in Central African Republic to that in China?
Make the answer very short. 0.01. What is the ratio of the Trade (in US$) in 1961 in Central African Republic to that in China?
Keep it short and to the point. 0.03. What is the ratio of the Trade (in US$) of 1962 in Central African Republic to that in China?
Your answer should be very brief. 0.03. What is the ratio of the Trade (in US$) in 1963 in Central African Republic to that in China?
Provide a succinct answer. 0.03. What is the ratio of the Trade (in US$) in 1960 in Chad to that in Chile?
Give a very brief answer. 0.08. What is the ratio of the Trade (in US$) of 1961 in Chad to that in Chile?
Provide a succinct answer. 0.08. What is the ratio of the Trade (in US$) of 1962 in Chad to that in Chile?
Your response must be concise. 0.09. What is the ratio of the Trade (in US$) in 1963 in Chad to that in Chile?
Keep it short and to the point. 0.09. What is the ratio of the Trade (in US$) of 1960 in Chad to that in China?
Make the answer very short. 0.02. What is the ratio of the Trade (in US$) in 1961 in Chad to that in China?
Provide a short and direct response. 0.04. What is the ratio of the Trade (in US$) of 1962 in Chad to that in China?
Your answer should be compact. 0.05. What is the ratio of the Trade (in US$) of 1963 in Chad to that in China?
Keep it short and to the point. 0.05. What is the ratio of the Trade (in US$) of 1960 in Chile to that in China?
Offer a terse response. 0.25. What is the ratio of the Trade (in US$) of 1961 in Chile to that in China?
Ensure brevity in your answer.  0.43. What is the ratio of the Trade (in US$) in 1962 in Chile to that in China?
Ensure brevity in your answer.  0.55. What is the ratio of the Trade (in US$) of 1963 in Chile to that in China?
Your answer should be compact. 0.55. What is the difference between the highest and the second highest Trade (in US$) of 1960?
Provide a short and direct response. 4.81e+09. What is the difference between the highest and the second highest Trade (in US$) in 1961?
Your answer should be compact. 5.61e+09. What is the difference between the highest and the second highest Trade (in US$) of 1962?
Keep it short and to the point. 6.10e+09. What is the difference between the highest and the second highest Trade (in US$) in 1963?
Provide a short and direct response. 6.34e+09. What is the difference between the highest and the lowest Trade (in US$) in 1960?
Make the answer very short. 7.43e+09. What is the difference between the highest and the lowest Trade (in US$) in 1961?
Ensure brevity in your answer.  7.33e+09. What is the difference between the highest and the lowest Trade (in US$) of 1962?
Your answer should be very brief. 7.43e+09. What is the difference between the highest and the lowest Trade (in US$) of 1963?
Your response must be concise. 7.76e+09. 